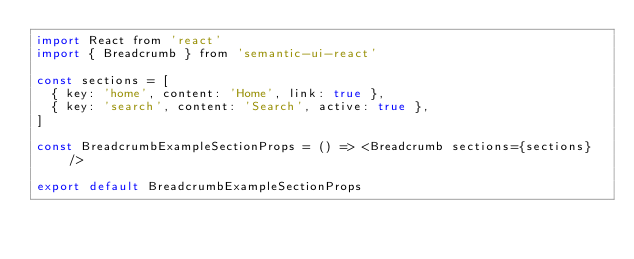Convert code to text. <code><loc_0><loc_0><loc_500><loc_500><_JavaScript_>import React from 'react'
import { Breadcrumb } from 'semantic-ui-react'

const sections = [
  { key: 'home', content: 'Home', link: true },
  { key: 'search', content: 'Search', active: true },
]

const BreadcrumbExampleSectionProps = () => <Breadcrumb sections={sections} />

export default BreadcrumbExampleSectionProps
</code> 